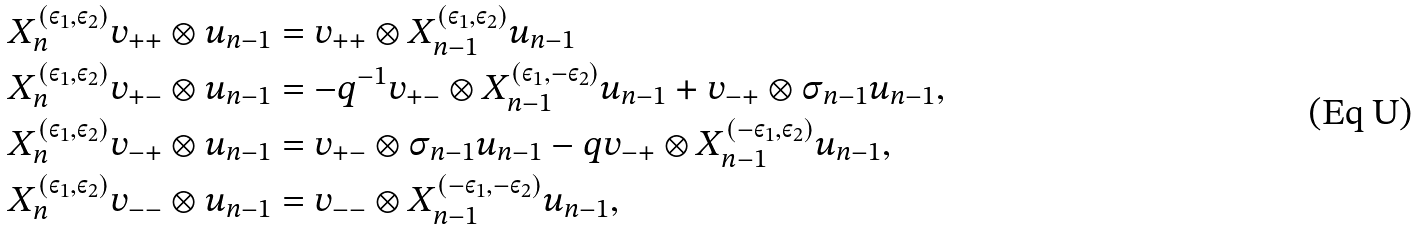<formula> <loc_0><loc_0><loc_500><loc_500>& X ^ { ( \varepsilon _ { 1 } , \varepsilon _ { 2 } ) } _ { n } v _ { + + } \otimes u _ { n - 1 } = v _ { + + } \otimes X ^ { ( \varepsilon _ { 1 } , \varepsilon _ { 2 } ) } _ { n - 1 } u _ { n - 1 } \\ & X ^ { ( \varepsilon _ { 1 } , \varepsilon _ { 2 } ) } _ { n } v _ { + - } \otimes u _ { n - 1 } = - q ^ { - 1 } v _ { + - } \otimes X ^ { ( \varepsilon _ { 1 } , - \varepsilon _ { 2 } ) } _ { n - 1 } u _ { n - 1 } + v _ { - + } \otimes { \sigma } _ { n - 1 } u _ { n - 1 } , \\ & X ^ { ( \varepsilon _ { 1 } , \varepsilon _ { 2 } ) } _ { n } v _ { - + } \otimes u _ { n - 1 } = v _ { + - } \otimes { \sigma } _ { n - 1 } u _ { n - 1 } - q v _ { - + } \otimes X ^ { ( - \varepsilon _ { 1 } , \varepsilon _ { 2 } ) } _ { n - 1 } u _ { n - 1 } , \\ & X ^ { ( \varepsilon _ { 1 } , \varepsilon _ { 2 } ) } _ { n } v _ { - - } \otimes u _ { n - 1 } = v _ { - - } \otimes X ^ { ( - \varepsilon _ { 1 } , - \varepsilon _ { 2 } ) } _ { n - 1 } u _ { n - 1 } ,</formula> 